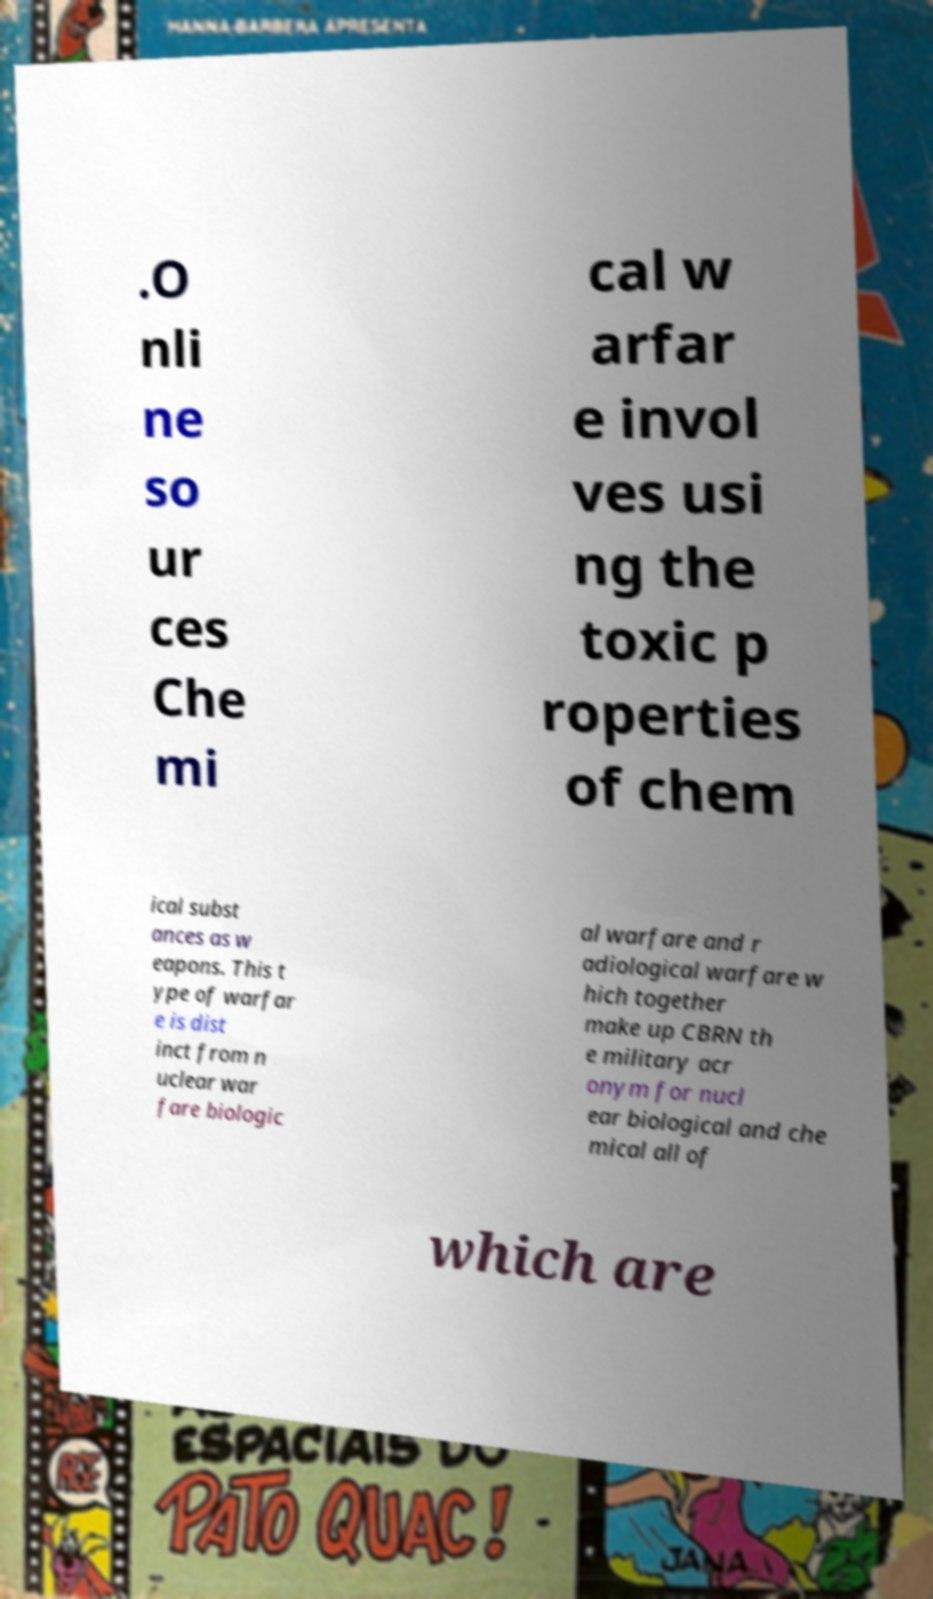I need the written content from this picture converted into text. Can you do that? .O nli ne so ur ces Che mi cal w arfar e invol ves usi ng the toxic p roperties of chem ical subst ances as w eapons. This t ype of warfar e is dist inct from n uclear war fare biologic al warfare and r adiological warfare w hich together make up CBRN th e military acr onym for nucl ear biological and che mical all of which are 